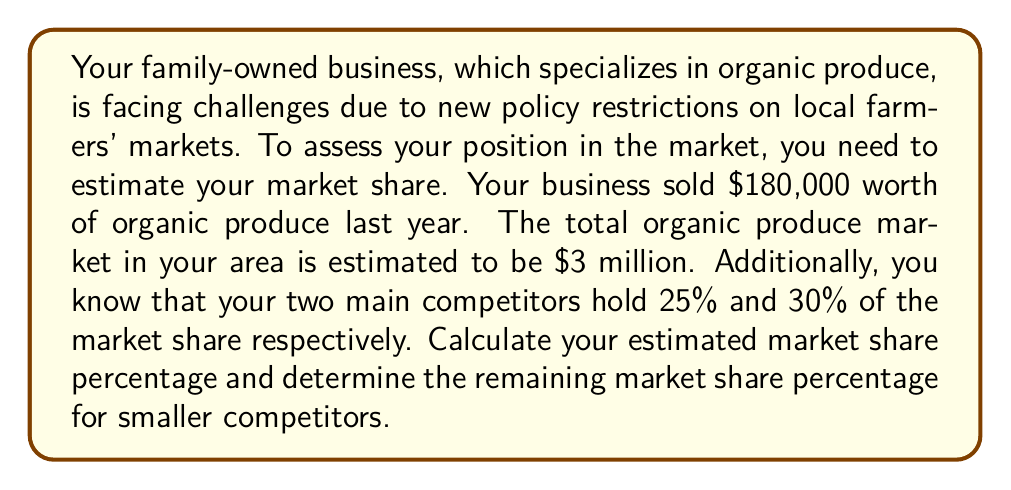Give your solution to this math problem. To solve this problem, we'll follow these steps:

1. Calculate your market share:
   Let's define your market share as $x$.
   $$x = \frac{\text{Your sales}}{\text{Total market size}} \times 100\%$$
   $$x = \frac{\$180,000}{\$3,000,000} \times 100\% = 0.06 \times 100\% = 6\%$$

2. Calculate the total market share of your business and the two main competitors:
   $$\text{Total share} = 6\% + 25\% + 30\% = 61\%$$

3. Calculate the remaining market share for smaller competitors:
   $$\text{Remaining share} = 100\% - 61\% = 39\%$$

This analysis shows that despite the policy restrictions, your family business holds a 6% market share in the local organic produce market. The two main competitors together control 55% of the market, leaving 39% for smaller competitors.
Answer: Your estimated market share is 6%, and the remaining market share for smaller competitors is 39%. 